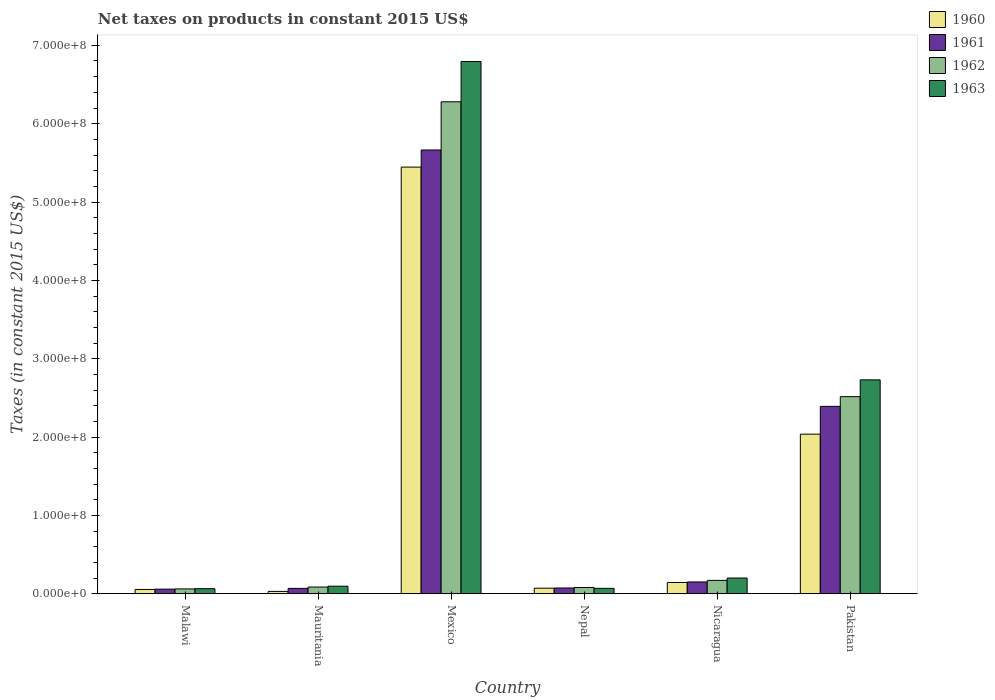Are the number of bars per tick equal to the number of legend labels?
Your response must be concise. Yes. Are the number of bars on each tick of the X-axis equal?
Keep it short and to the point. Yes. How many bars are there on the 1st tick from the left?
Make the answer very short. 4. What is the label of the 2nd group of bars from the left?
Your answer should be very brief. Mauritania. In how many cases, is the number of bars for a given country not equal to the number of legend labels?
Offer a very short reply. 0. What is the net taxes on products in 1963 in Nicaragua?
Give a very brief answer. 2.01e+07. Across all countries, what is the maximum net taxes on products in 1960?
Offer a very short reply. 5.45e+08. Across all countries, what is the minimum net taxes on products in 1960?
Provide a succinct answer. 3.00e+06. In which country was the net taxes on products in 1960 maximum?
Offer a very short reply. Mexico. In which country was the net taxes on products in 1960 minimum?
Your answer should be compact. Mauritania. What is the total net taxes on products in 1960 in the graph?
Provide a short and direct response. 7.78e+08. What is the difference between the net taxes on products in 1963 in Mexico and that in Pakistan?
Your answer should be very brief. 4.06e+08. What is the difference between the net taxes on products in 1961 in Malawi and the net taxes on products in 1963 in Nicaragua?
Provide a succinct answer. -1.42e+07. What is the average net taxes on products in 1963 per country?
Offer a terse response. 1.66e+08. What is the difference between the net taxes on products of/in 1962 and net taxes on products of/in 1960 in Malawi?
Give a very brief answer. 7.00e+05. What is the ratio of the net taxes on products in 1960 in Nicaragua to that in Pakistan?
Your answer should be very brief. 0.07. Is the difference between the net taxes on products in 1962 in Nepal and Pakistan greater than the difference between the net taxes on products in 1960 in Nepal and Pakistan?
Keep it short and to the point. No. What is the difference between the highest and the second highest net taxes on products in 1960?
Your answer should be compact. 1.89e+08. What is the difference between the highest and the lowest net taxes on products in 1960?
Your answer should be very brief. 5.42e+08. Is it the case that in every country, the sum of the net taxes on products in 1960 and net taxes on products in 1961 is greater than the sum of net taxes on products in 1963 and net taxes on products in 1962?
Your answer should be very brief. No. What does the 1st bar from the left in Mauritania represents?
Offer a very short reply. 1960. What does the 1st bar from the right in Mexico represents?
Provide a succinct answer. 1963. Is it the case that in every country, the sum of the net taxes on products in 1960 and net taxes on products in 1963 is greater than the net taxes on products in 1961?
Ensure brevity in your answer.  Yes. Are the values on the major ticks of Y-axis written in scientific E-notation?
Your answer should be very brief. Yes. Does the graph contain any zero values?
Your response must be concise. No. Does the graph contain grids?
Make the answer very short. No. What is the title of the graph?
Your answer should be compact. Net taxes on products in constant 2015 US$. What is the label or title of the X-axis?
Give a very brief answer. Country. What is the label or title of the Y-axis?
Provide a succinct answer. Taxes (in constant 2015 US$). What is the Taxes (in constant 2015 US$) of 1960 in Malawi?
Your answer should be compact. 5.46e+06. What is the Taxes (in constant 2015 US$) of 1961 in Malawi?
Provide a short and direct response. 5.88e+06. What is the Taxes (in constant 2015 US$) of 1962 in Malawi?
Your response must be concise. 6.16e+06. What is the Taxes (in constant 2015 US$) in 1963 in Malawi?
Offer a very short reply. 6.44e+06. What is the Taxes (in constant 2015 US$) in 1960 in Mauritania?
Provide a succinct answer. 3.00e+06. What is the Taxes (in constant 2015 US$) in 1961 in Mauritania?
Your answer should be very brief. 6.85e+06. What is the Taxes (in constant 2015 US$) in 1962 in Mauritania?
Your answer should be very brief. 8.56e+06. What is the Taxes (in constant 2015 US$) of 1963 in Mauritania?
Provide a succinct answer. 9.63e+06. What is the Taxes (in constant 2015 US$) in 1960 in Mexico?
Make the answer very short. 5.45e+08. What is the Taxes (in constant 2015 US$) in 1961 in Mexico?
Ensure brevity in your answer.  5.66e+08. What is the Taxes (in constant 2015 US$) of 1962 in Mexico?
Offer a very short reply. 6.28e+08. What is the Taxes (in constant 2015 US$) in 1963 in Mexico?
Offer a terse response. 6.79e+08. What is the Taxes (in constant 2015 US$) in 1960 in Nepal?
Offer a very short reply. 7.09e+06. What is the Taxes (in constant 2015 US$) of 1961 in Nepal?
Ensure brevity in your answer.  7.35e+06. What is the Taxes (in constant 2015 US$) of 1962 in Nepal?
Your answer should be very brief. 8.01e+06. What is the Taxes (in constant 2015 US$) of 1963 in Nepal?
Make the answer very short. 6.89e+06. What is the Taxes (in constant 2015 US$) in 1960 in Nicaragua?
Give a very brief answer. 1.44e+07. What is the Taxes (in constant 2015 US$) of 1961 in Nicaragua?
Make the answer very short. 1.51e+07. What is the Taxes (in constant 2015 US$) of 1962 in Nicaragua?
Ensure brevity in your answer.  1.71e+07. What is the Taxes (in constant 2015 US$) in 1963 in Nicaragua?
Your answer should be very brief. 2.01e+07. What is the Taxes (in constant 2015 US$) in 1960 in Pakistan?
Provide a succinct answer. 2.04e+08. What is the Taxes (in constant 2015 US$) in 1961 in Pakistan?
Your response must be concise. 2.39e+08. What is the Taxes (in constant 2015 US$) of 1962 in Pakistan?
Your answer should be compact. 2.52e+08. What is the Taxes (in constant 2015 US$) of 1963 in Pakistan?
Offer a very short reply. 2.73e+08. Across all countries, what is the maximum Taxes (in constant 2015 US$) of 1960?
Your response must be concise. 5.45e+08. Across all countries, what is the maximum Taxes (in constant 2015 US$) of 1961?
Your answer should be compact. 5.66e+08. Across all countries, what is the maximum Taxes (in constant 2015 US$) of 1962?
Ensure brevity in your answer.  6.28e+08. Across all countries, what is the maximum Taxes (in constant 2015 US$) in 1963?
Your answer should be compact. 6.79e+08. Across all countries, what is the minimum Taxes (in constant 2015 US$) in 1960?
Give a very brief answer. 3.00e+06. Across all countries, what is the minimum Taxes (in constant 2015 US$) in 1961?
Make the answer very short. 5.88e+06. Across all countries, what is the minimum Taxes (in constant 2015 US$) in 1962?
Ensure brevity in your answer.  6.16e+06. Across all countries, what is the minimum Taxes (in constant 2015 US$) of 1963?
Give a very brief answer. 6.44e+06. What is the total Taxes (in constant 2015 US$) in 1960 in the graph?
Provide a short and direct response. 7.78e+08. What is the total Taxes (in constant 2015 US$) of 1961 in the graph?
Offer a terse response. 8.41e+08. What is the total Taxes (in constant 2015 US$) of 1962 in the graph?
Provide a succinct answer. 9.19e+08. What is the total Taxes (in constant 2015 US$) of 1963 in the graph?
Make the answer very short. 9.95e+08. What is the difference between the Taxes (in constant 2015 US$) in 1960 in Malawi and that in Mauritania?
Your answer should be very brief. 2.46e+06. What is the difference between the Taxes (in constant 2015 US$) of 1961 in Malawi and that in Mauritania?
Make the answer very short. -9.67e+05. What is the difference between the Taxes (in constant 2015 US$) of 1962 in Malawi and that in Mauritania?
Keep it short and to the point. -2.40e+06. What is the difference between the Taxes (in constant 2015 US$) of 1963 in Malawi and that in Mauritania?
Offer a very short reply. -3.19e+06. What is the difference between the Taxes (in constant 2015 US$) of 1960 in Malawi and that in Mexico?
Your response must be concise. -5.39e+08. What is the difference between the Taxes (in constant 2015 US$) in 1961 in Malawi and that in Mexico?
Your answer should be compact. -5.61e+08. What is the difference between the Taxes (in constant 2015 US$) of 1962 in Malawi and that in Mexico?
Ensure brevity in your answer.  -6.22e+08. What is the difference between the Taxes (in constant 2015 US$) of 1963 in Malawi and that in Mexico?
Give a very brief answer. -6.73e+08. What is the difference between the Taxes (in constant 2015 US$) of 1960 in Malawi and that in Nepal?
Offer a terse response. -1.63e+06. What is the difference between the Taxes (in constant 2015 US$) in 1961 in Malawi and that in Nepal?
Give a very brief answer. -1.47e+06. What is the difference between the Taxes (in constant 2015 US$) of 1962 in Malawi and that in Nepal?
Your answer should be compact. -1.85e+06. What is the difference between the Taxes (in constant 2015 US$) in 1963 in Malawi and that in Nepal?
Make the answer very short. -4.50e+05. What is the difference between the Taxes (in constant 2015 US$) in 1960 in Malawi and that in Nicaragua?
Your response must be concise. -8.93e+06. What is the difference between the Taxes (in constant 2015 US$) of 1961 in Malawi and that in Nicaragua?
Give a very brief answer. -9.18e+06. What is the difference between the Taxes (in constant 2015 US$) in 1962 in Malawi and that in Nicaragua?
Make the answer very short. -1.09e+07. What is the difference between the Taxes (in constant 2015 US$) in 1963 in Malawi and that in Nicaragua?
Offer a very short reply. -1.36e+07. What is the difference between the Taxes (in constant 2015 US$) in 1960 in Malawi and that in Pakistan?
Offer a terse response. -1.98e+08. What is the difference between the Taxes (in constant 2015 US$) in 1961 in Malawi and that in Pakistan?
Offer a very short reply. -2.33e+08. What is the difference between the Taxes (in constant 2015 US$) in 1962 in Malawi and that in Pakistan?
Offer a very short reply. -2.45e+08. What is the difference between the Taxes (in constant 2015 US$) of 1963 in Malawi and that in Pakistan?
Your response must be concise. -2.67e+08. What is the difference between the Taxes (in constant 2015 US$) in 1960 in Mauritania and that in Mexico?
Give a very brief answer. -5.42e+08. What is the difference between the Taxes (in constant 2015 US$) of 1961 in Mauritania and that in Mexico?
Your answer should be very brief. -5.60e+08. What is the difference between the Taxes (in constant 2015 US$) of 1962 in Mauritania and that in Mexico?
Keep it short and to the point. -6.19e+08. What is the difference between the Taxes (in constant 2015 US$) in 1963 in Mauritania and that in Mexico?
Provide a short and direct response. -6.70e+08. What is the difference between the Taxes (in constant 2015 US$) of 1960 in Mauritania and that in Nepal?
Your answer should be compact. -4.09e+06. What is the difference between the Taxes (in constant 2015 US$) in 1961 in Mauritania and that in Nepal?
Your answer should be compact. -5.03e+05. What is the difference between the Taxes (in constant 2015 US$) in 1962 in Mauritania and that in Nepal?
Ensure brevity in your answer.  5.53e+05. What is the difference between the Taxes (in constant 2015 US$) of 1963 in Mauritania and that in Nepal?
Offer a terse response. 2.74e+06. What is the difference between the Taxes (in constant 2015 US$) of 1960 in Mauritania and that in Nicaragua?
Ensure brevity in your answer.  -1.14e+07. What is the difference between the Taxes (in constant 2015 US$) in 1961 in Mauritania and that in Nicaragua?
Offer a terse response. -8.21e+06. What is the difference between the Taxes (in constant 2015 US$) in 1962 in Mauritania and that in Nicaragua?
Your answer should be compact. -8.50e+06. What is the difference between the Taxes (in constant 2015 US$) in 1963 in Mauritania and that in Nicaragua?
Make the answer very short. -1.04e+07. What is the difference between the Taxes (in constant 2015 US$) of 1960 in Mauritania and that in Pakistan?
Keep it short and to the point. -2.01e+08. What is the difference between the Taxes (in constant 2015 US$) in 1961 in Mauritania and that in Pakistan?
Your answer should be compact. -2.32e+08. What is the difference between the Taxes (in constant 2015 US$) in 1962 in Mauritania and that in Pakistan?
Ensure brevity in your answer.  -2.43e+08. What is the difference between the Taxes (in constant 2015 US$) in 1963 in Mauritania and that in Pakistan?
Make the answer very short. -2.63e+08. What is the difference between the Taxes (in constant 2015 US$) of 1960 in Mexico and that in Nepal?
Ensure brevity in your answer.  5.37e+08. What is the difference between the Taxes (in constant 2015 US$) in 1961 in Mexico and that in Nepal?
Keep it short and to the point. 5.59e+08. What is the difference between the Taxes (in constant 2015 US$) of 1962 in Mexico and that in Nepal?
Provide a succinct answer. 6.20e+08. What is the difference between the Taxes (in constant 2015 US$) of 1963 in Mexico and that in Nepal?
Your answer should be compact. 6.72e+08. What is the difference between the Taxes (in constant 2015 US$) of 1960 in Mexico and that in Nicaragua?
Ensure brevity in your answer.  5.30e+08. What is the difference between the Taxes (in constant 2015 US$) of 1961 in Mexico and that in Nicaragua?
Offer a very short reply. 5.51e+08. What is the difference between the Taxes (in constant 2015 US$) of 1962 in Mexico and that in Nicaragua?
Ensure brevity in your answer.  6.11e+08. What is the difference between the Taxes (in constant 2015 US$) in 1963 in Mexico and that in Nicaragua?
Your answer should be compact. 6.59e+08. What is the difference between the Taxes (in constant 2015 US$) of 1960 in Mexico and that in Pakistan?
Keep it short and to the point. 3.41e+08. What is the difference between the Taxes (in constant 2015 US$) in 1961 in Mexico and that in Pakistan?
Your response must be concise. 3.27e+08. What is the difference between the Taxes (in constant 2015 US$) of 1962 in Mexico and that in Pakistan?
Offer a very short reply. 3.76e+08. What is the difference between the Taxes (in constant 2015 US$) of 1963 in Mexico and that in Pakistan?
Your answer should be compact. 4.06e+08. What is the difference between the Taxes (in constant 2015 US$) of 1960 in Nepal and that in Nicaragua?
Give a very brief answer. -7.30e+06. What is the difference between the Taxes (in constant 2015 US$) of 1961 in Nepal and that in Nicaragua?
Provide a succinct answer. -7.71e+06. What is the difference between the Taxes (in constant 2015 US$) in 1962 in Nepal and that in Nicaragua?
Offer a very short reply. -9.06e+06. What is the difference between the Taxes (in constant 2015 US$) in 1963 in Nepal and that in Nicaragua?
Your answer should be very brief. -1.32e+07. What is the difference between the Taxes (in constant 2015 US$) of 1960 in Nepal and that in Pakistan?
Provide a short and direct response. -1.97e+08. What is the difference between the Taxes (in constant 2015 US$) of 1961 in Nepal and that in Pakistan?
Ensure brevity in your answer.  -2.32e+08. What is the difference between the Taxes (in constant 2015 US$) in 1962 in Nepal and that in Pakistan?
Make the answer very short. -2.44e+08. What is the difference between the Taxes (in constant 2015 US$) of 1963 in Nepal and that in Pakistan?
Keep it short and to the point. -2.66e+08. What is the difference between the Taxes (in constant 2015 US$) of 1960 in Nicaragua and that in Pakistan?
Give a very brief answer. -1.89e+08. What is the difference between the Taxes (in constant 2015 US$) of 1961 in Nicaragua and that in Pakistan?
Offer a terse response. -2.24e+08. What is the difference between the Taxes (in constant 2015 US$) in 1962 in Nicaragua and that in Pakistan?
Your answer should be very brief. -2.35e+08. What is the difference between the Taxes (in constant 2015 US$) of 1963 in Nicaragua and that in Pakistan?
Give a very brief answer. -2.53e+08. What is the difference between the Taxes (in constant 2015 US$) of 1960 in Malawi and the Taxes (in constant 2015 US$) of 1961 in Mauritania?
Provide a short and direct response. -1.39e+06. What is the difference between the Taxes (in constant 2015 US$) in 1960 in Malawi and the Taxes (in constant 2015 US$) in 1962 in Mauritania?
Your answer should be compact. -3.10e+06. What is the difference between the Taxes (in constant 2015 US$) of 1960 in Malawi and the Taxes (in constant 2015 US$) of 1963 in Mauritania?
Keep it short and to the point. -4.17e+06. What is the difference between the Taxes (in constant 2015 US$) of 1961 in Malawi and the Taxes (in constant 2015 US$) of 1962 in Mauritania?
Ensure brevity in your answer.  -2.68e+06. What is the difference between the Taxes (in constant 2015 US$) in 1961 in Malawi and the Taxes (in constant 2015 US$) in 1963 in Mauritania?
Keep it short and to the point. -3.75e+06. What is the difference between the Taxes (in constant 2015 US$) of 1962 in Malawi and the Taxes (in constant 2015 US$) of 1963 in Mauritania?
Your answer should be very brief. -3.47e+06. What is the difference between the Taxes (in constant 2015 US$) of 1960 in Malawi and the Taxes (in constant 2015 US$) of 1961 in Mexico?
Your answer should be very brief. -5.61e+08. What is the difference between the Taxes (in constant 2015 US$) in 1960 in Malawi and the Taxes (in constant 2015 US$) in 1962 in Mexico?
Your response must be concise. -6.22e+08. What is the difference between the Taxes (in constant 2015 US$) in 1960 in Malawi and the Taxes (in constant 2015 US$) in 1963 in Mexico?
Your answer should be compact. -6.74e+08. What is the difference between the Taxes (in constant 2015 US$) of 1961 in Malawi and the Taxes (in constant 2015 US$) of 1962 in Mexico?
Provide a succinct answer. -6.22e+08. What is the difference between the Taxes (in constant 2015 US$) in 1961 in Malawi and the Taxes (in constant 2015 US$) in 1963 in Mexico?
Offer a terse response. -6.73e+08. What is the difference between the Taxes (in constant 2015 US$) in 1962 in Malawi and the Taxes (in constant 2015 US$) in 1963 in Mexico?
Your answer should be compact. -6.73e+08. What is the difference between the Taxes (in constant 2015 US$) of 1960 in Malawi and the Taxes (in constant 2015 US$) of 1961 in Nepal?
Your answer should be compact. -1.89e+06. What is the difference between the Taxes (in constant 2015 US$) in 1960 in Malawi and the Taxes (in constant 2015 US$) in 1962 in Nepal?
Provide a short and direct response. -2.55e+06. What is the difference between the Taxes (in constant 2015 US$) of 1960 in Malawi and the Taxes (in constant 2015 US$) of 1963 in Nepal?
Your response must be concise. -1.43e+06. What is the difference between the Taxes (in constant 2015 US$) of 1961 in Malawi and the Taxes (in constant 2015 US$) of 1962 in Nepal?
Give a very brief answer. -2.13e+06. What is the difference between the Taxes (in constant 2015 US$) in 1961 in Malawi and the Taxes (in constant 2015 US$) in 1963 in Nepal?
Your answer should be compact. -1.01e+06. What is the difference between the Taxes (in constant 2015 US$) of 1962 in Malawi and the Taxes (in constant 2015 US$) of 1963 in Nepal?
Your response must be concise. -7.30e+05. What is the difference between the Taxes (in constant 2015 US$) in 1960 in Malawi and the Taxes (in constant 2015 US$) in 1961 in Nicaragua?
Provide a short and direct response. -9.60e+06. What is the difference between the Taxes (in constant 2015 US$) of 1960 in Malawi and the Taxes (in constant 2015 US$) of 1962 in Nicaragua?
Offer a very short reply. -1.16e+07. What is the difference between the Taxes (in constant 2015 US$) of 1960 in Malawi and the Taxes (in constant 2015 US$) of 1963 in Nicaragua?
Provide a succinct answer. -1.46e+07. What is the difference between the Taxes (in constant 2015 US$) of 1961 in Malawi and the Taxes (in constant 2015 US$) of 1962 in Nicaragua?
Your response must be concise. -1.12e+07. What is the difference between the Taxes (in constant 2015 US$) in 1961 in Malawi and the Taxes (in constant 2015 US$) in 1963 in Nicaragua?
Your answer should be compact. -1.42e+07. What is the difference between the Taxes (in constant 2015 US$) in 1962 in Malawi and the Taxes (in constant 2015 US$) in 1963 in Nicaragua?
Offer a terse response. -1.39e+07. What is the difference between the Taxes (in constant 2015 US$) of 1960 in Malawi and the Taxes (in constant 2015 US$) of 1961 in Pakistan?
Offer a very short reply. -2.34e+08. What is the difference between the Taxes (in constant 2015 US$) of 1960 in Malawi and the Taxes (in constant 2015 US$) of 1962 in Pakistan?
Make the answer very short. -2.46e+08. What is the difference between the Taxes (in constant 2015 US$) in 1960 in Malawi and the Taxes (in constant 2015 US$) in 1963 in Pakistan?
Your response must be concise. -2.68e+08. What is the difference between the Taxes (in constant 2015 US$) in 1961 in Malawi and the Taxes (in constant 2015 US$) in 1962 in Pakistan?
Your answer should be very brief. -2.46e+08. What is the difference between the Taxes (in constant 2015 US$) in 1961 in Malawi and the Taxes (in constant 2015 US$) in 1963 in Pakistan?
Ensure brevity in your answer.  -2.67e+08. What is the difference between the Taxes (in constant 2015 US$) of 1962 in Malawi and the Taxes (in constant 2015 US$) of 1963 in Pakistan?
Provide a succinct answer. -2.67e+08. What is the difference between the Taxes (in constant 2015 US$) of 1960 in Mauritania and the Taxes (in constant 2015 US$) of 1961 in Mexico?
Your answer should be compact. -5.63e+08. What is the difference between the Taxes (in constant 2015 US$) of 1960 in Mauritania and the Taxes (in constant 2015 US$) of 1962 in Mexico?
Provide a short and direct response. -6.25e+08. What is the difference between the Taxes (in constant 2015 US$) of 1960 in Mauritania and the Taxes (in constant 2015 US$) of 1963 in Mexico?
Provide a succinct answer. -6.76e+08. What is the difference between the Taxes (in constant 2015 US$) of 1961 in Mauritania and the Taxes (in constant 2015 US$) of 1962 in Mexico?
Your response must be concise. -6.21e+08. What is the difference between the Taxes (in constant 2015 US$) in 1961 in Mauritania and the Taxes (in constant 2015 US$) in 1963 in Mexico?
Provide a short and direct response. -6.73e+08. What is the difference between the Taxes (in constant 2015 US$) of 1962 in Mauritania and the Taxes (in constant 2015 US$) of 1963 in Mexico?
Give a very brief answer. -6.71e+08. What is the difference between the Taxes (in constant 2015 US$) in 1960 in Mauritania and the Taxes (in constant 2015 US$) in 1961 in Nepal?
Offer a very short reply. -4.35e+06. What is the difference between the Taxes (in constant 2015 US$) of 1960 in Mauritania and the Taxes (in constant 2015 US$) of 1962 in Nepal?
Provide a succinct answer. -5.01e+06. What is the difference between the Taxes (in constant 2015 US$) in 1960 in Mauritania and the Taxes (in constant 2015 US$) in 1963 in Nepal?
Keep it short and to the point. -3.89e+06. What is the difference between the Taxes (in constant 2015 US$) of 1961 in Mauritania and the Taxes (in constant 2015 US$) of 1962 in Nepal?
Ensure brevity in your answer.  -1.16e+06. What is the difference between the Taxes (in constant 2015 US$) in 1961 in Mauritania and the Taxes (in constant 2015 US$) in 1963 in Nepal?
Make the answer very short. -4.29e+04. What is the difference between the Taxes (in constant 2015 US$) of 1962 in Mauritania and the Taxes (in constant 2015 US$) of 1963 in Nepal?
Ensure brevity in your answer.  1.67e+06. What is the difference between the Taxes (in constant 2015 US$) of 1960 in Mauritania and the Taxes (in constant 2015 US$) of 1961 in Nicaragua?
Your response must be concise. -1.21e+07. What is the difference between the Taxes (in constant 2015 US$) of 1960 in Mauritania and the Taxes (in constant 2015 US$) of 1962 in Nicaragua?
Provide a succinct answer. -1.41e+07. What is the difference between the Taxes (in constant 2015 US$) of 1960 in Mauritania and the Taxes (in constant 2015 US$) of 1963 in Nicaragua?
Your response must be concise. -1.71e+07. What is the difference between the Taxes (in constant 2015 US$) of 1961 in Mauritania and the Taxes (in constant 2015 US$) of 1962 in Nicaragua?
Ensure brevity in your answer.  -1.02e+07. What is the difference between the Taxes (in constant 2015 US$) in 1961 in Mauritania and the Taxes (in constant 2015 US$) in 1963 in Nicaragua?
Your response must be concise. -1.32e+07. What is the difference between the Taxes (in constant 2015 US$) of 1962 in Mauritania and the Taxes (in constant 2015 US$) of 1963 in Nicaragua?
Give a very brief answer. -1.15e+07. What is the difference between the Taxes (in constant 2015 US$) of 1960 in Mauritania and the Taxes (in constant 2015 US$) of 1961 in Pakistan?
Provide a succinct answer. -2.36e+08. What is the difference between the Taxes (in constant 2015 US$) in 1960 in Mauritania and the Taxes (in constant 2015 US$) in 1962 in Pakistan?
Offer a very short reply. -2.49e+08. What is the difference between the Taxes (in constant 2015 US$) of 1960 in Mauritania and the Taxes (in constant 2015 US$) of 1963 in Pakistan?
Provide a short and direct response. -2.70e+08. What is the difference between the Taxes (in constant 2015 US$) in 1961 in Mauritania and the Taxes (in constant 2015 US$) in 1962 in Pakistan?
Provide a succinct answer. -2.45e+08. What is the difference between the Taxes (in constant 2015 US$) in 1961 in Mauritania and the Taxes (in constant 2015 US$) in 1963 in Pakistan?
Provide a short and direct response. -2.66e+08. What is the difference between the Taxes (in constant 2015 US$) in 1962 in Mauritania and the Taxes (in constant 2015 US$) in 1963 in Pakistan?
Provide a succinct answer. -2.64e+08. What is the difference between the Taxes (in constant 2015 US$) of 1960 in Mexico and the Taxes (in constant 2015 US$) of 1961 in Nepal?
Keep it short and to the point. 5.37e+08. What is the difference between the Taxes (in constant 2015 US$) of 1960 in Mexico and the Taxes (in constant 2015 US$) of 1962 in Nepal?
Keep it short and to the point. 5.37e+08. What is the difference between the Taxes (in constant 2015 US$) in 1960 in Mexico and the Taxes (in constant 2015 US$) in 1963 in Nepal?
Give a very brief answer. 5.38e+08. What is the difference between the Taxes (in constant 2015 US$) in 1961 in Mexico and the Taxes (in constant 2015 US$) in 1962 in Nepal?
Your answer should be very brief. 5.58e+08. What is the difference between the Taxes (in constant 2015 US$) in 1961 in Mexico and the Taxes (in constant 2015 US$) in 1963 in Nepal?
Provide a succinct answer. 5.60e+08. What is the difference between the Taxes (in constant 2015 US$) in 1962 in Mexico and the Taxes (in constant 2015 US$) in 1963 in Nepal?
Offer a terse response. 6.21e+08. What is the difference between the Taxes (in constant 2015 US$) in 1960 in Mexico and the Taxes (in constant 2015 US$) in 1961 in Nicaragua?
Ensure brevity in your answer.  5.30e+08. What is the difference between the Taxes (in constant 2015 US$) of 1960 in Mexico and the Taxes (in constant 2015 US$) of 1962 in Nicaragua?
Provide a succinct answer. 5.28e+08. What is the difference between the Taxes (in constant 2015 US$) in 1960 in Mexico and the Taxes (in constant 2015 US$) in 1963 in Nicaragua?
Give a very brief answer. 5.24e+08. What is the difference between the Taxes (in constant 2015 US$) in 1961 in Mexico and the Taxes (in constant 2015 US$) in 1962 in Nicaragua?
Your response must be concise. 5.49e+08. What is the difference between the Taxes (in constant 2015 US$) of 1961 in Mexico and the Taxes (in constant 2015 US$) of 1963 in Nicaragua?
Keep it short and to the point. 5.46e+08. What is the difference between the Taxes (in constant 2015 US$) of 1962 in Mexico and the Taxes (in constant 2015 US$) of 1963 in Nicaragua?
Your answer should be compact. 6.08e+08. What is the difference between the Taxes (in constant 2015 US$) in 1960 in Mexico and the Taxes (in constant 2015 US$) in 1961 in Pakistan?
Your response must be concise. 3.05e+08. What is the difference between the Taxes (in constant 2015 US$) in 1960 in Mexico and the Taxes (in constant 2015 US$) in 1962 in Pakistan?
Ensure brevity in your answer.  2.93e+08. What is the difference between the Taxes (in constant 2015 US$) of 1960 in Mexico and the Taxes (in constant 2015 US$) of 1963 in Pakistan?
Offer a terse response. 2.72e+08. What is the difference between the Taxes (in constant 2015 US$) of 1961 in Mexico and the Taxes (in constant 2015 US$) of 1962 in Pakistan?
Provide a short and direct response. 3.15e+08. What is the difference between the Taxes (in constant 2015 US$) in 1961 in Mexico and the Taxes (in constant 2015 US$) in 1963 in Pakistan?
Keep it short and to the point. 2.93e+08. What is the difference between the Taxes (in constant 2015 US$) of 1962 in Mexico and the Taxes (in constant 2015 US$) of 1963 in Pakistan?
Your response must be concise. 3.55e+08. What is the difference between the Taxes (in constant 2015 US$) in 1960 in Nepal and the Taxes (in constant 2015 US$) in 1961 in Nicaragua?
Offer a very short reply. -7.97e+06. What is the difference between the Taxes (in constant 2015 US$) in 1960 in Nepal and the Taxes (in constant 2015 US$) in 1962 in Nicaragua?
Make the answer very short. -9.98e+06. What is the difference between the Taxes (in constant 2015 US$) of 1960 in Nepal and the Taxes (in constant 2015 US$) of 1963 in Nicaragua?
Your response must be concise. -1.30e+07. What is the difference between the Taxes (in constant 2015 US$) in 1961 in Nepal and the Taxes (in constant 2015 US$) in 1962 in Nicaragua?
Your response must be concise. -9.71e+06. What is the difference between the Taxes (in constant 2015 US$) in 1961 in Nepal and the Taxes (in constant 2015 US$) in 1963 in Nicaragua?
Your answer should be very brief. -1.27e+07. What is the difference between the Taxes (in constant 2015 US$) in 1962 in Nepal and the Taxes (in constant 2015 US$) in 1963 in Nicaragua?
Offer a terse response. -1.21e+07. What is the difference between the Taxes (in constant 2015 US$) of 1960 in Nepal and the Taxes (in constant 2015 US$) of 1961 in Pakistan?
Offer a terse response. -2.32e+08. What is the difference between the Taxes (in constant 2015 US$) in 1960 in Nepal and the Taxes (in constant 2015 US$) in 1962 in Pakistan?
Keep it short and to the point. -2.44e+08. What is the difference between the Taxes (in constant 2015 US$) in 1960 in Nepal and the Taxes (in constant 2015 US$) in 1963 in Pakistan?
Your response must be concise. -2.66e+08. What is the difference between the Taxes (in constant 2015 US$) in 1961 in Nepal and the Taxes (in constant 2015 US$) in 1962 in Pakistan?
Your answer should be compact. -2.44e+08. What is the difference between the Taxes (in constant 2015 US$) in 1961 in Nepal and the Taxes (in constant 2015 US$) in 1963 in Pakistan?
Your answer should be compact. -2.66e+08. What is the difference between the Taxes (in constant 2015 US$) of 1962 in Nepal and the Taxes (in constant 2015 US$) of 1963 in Pakistan?
Offer a very short reply. -2.65e+08. What is the difference between the Taxes (in constant 2015 US$) in 1960 in Nicaragua and the Taxes (in constant 2015 US$) in 1961 in Pakistan?
Your answer should be very brief. -2.25e+08. What is the difference between the Taxes (in constant 2015 US$) of 1960 in Nicaragua and the Taxes (in constant 2015 US$) of 1962 in Pakistan?
Offer a very short reply. -2.37e+08. What is the difference between the Taxes (in constant 2015 US$) in 1960 in Nicaragua and the Taxes (in constant 2015 US$) in 1963 in Pakistan?
Offer a very short reply. -2.59e+08. What is the difference between the Taxes (in constant 2015 US$) in 1961 in Nicaragua and the Taxes (in constant 2015 US$) in 1962 in Pakistan?
Your answer should be compact. -2.37e+08. What is the difference between the Taxes (in constant 2015 US$) in 1961 in Nicaragua and the Taxes (in constant 2015 US$) in 1963 in Pakistan?
Give a very brief answer. -2.58e+08. What is the difference between the Taxes (in constant 2015 US$) in 1962 in Nicaragua and the Taxes (in constant 2015 US$) in 1963 in Pakistan?
Your answer should be compact. -2.56e+08. What is the average Taxes (in constant 2015 US$) in 1960 per country?
Offer a very short reply. 1.30e+08. What is the average Taxes (in constant 2015 US$) of 1961 per country?
Your answer should be compact. 1.40e+08. What is the average Taxes (in constant 2015 US$) of 1962 per country?
Your answer should be very brief. 1.53e+08. What is the average Taxes (in constant 2015 US$) of 1963 per country?
Ensure brevity in your answer.  1.66e+08. What is the difference between the Taxes (in constant 2015 US$) in 1960 and Taxes (in constant 2015 US$) in 1961 in Malawi?
Ensure brevity in your answer.  -4.20e+05. What is the difference between the Taxes (in constant 2015 US$) of 1960 and Taxes (in constant 2015 US$) of 1962 in Malawi?
Give a very brief answer. -7.00e+05. What is the difference between the Taxes (in constant 2015 US$) in 1960 and Taxes (in constant 2015 US$) in 1963 in Malawi?
Give a very brief answer. -9.80e+05. What is the difference between the Taxes (in constant 2015 US$) of 1961 and Taxes (in constant 2015 US$) of 1962 in Malawi?
Make the answer very short. -2.80e+05. What is the difference between the Taxes (in constant 2015 US$) in 1961 and Taxes (in constant 2015 US$) in 1963 in Malawi?
Make the answer very short. -5.60e+05. What is the difference between the Taxes (in constant 2015 US$) in 1962 and Taxes (in constant 2015 US$) in 1963 in Malawi?
Make the answer very short. -2.80e+05. What is the difference between the Taxes (in constant 2015 US$) of 1960 and Taxes (in constant 2015 US$) of 1961 in Mauritania?
Your answer should be very brief. -3.85e+06. What is the difference between the Taxes (in constant 2015 US$) in 1960 and Taxes (in constant 2015 US$) in 1962 in Mauritania?
Your response must be concise. -5.56e+06. What is the difference between the Taxes (in constant 2015 US$) of 1960 and Taxes (in constant 2015 US$) of 1963 in Mauritania?
Offer a very short reply. -6.63e+06. What is the difference between the Taxes (in constant 2015 US$) in 1961 and Taxes (in constant 2015 US$) in 1962 in Mauritania?
Offer a terse response. -1.71e+06. What is the difference between the Taxes (in constant 2015 US$) of 1961 and Taxes (in constant 2015 US$) of 1963 in Mauritania?
Give a very brief answer. -2.78e+06. What is the difference between the Taxes (in constant 2015 US$) in 1962 and Taxes (in constant 2015 US$) in 1963 in Mauritania?
Keep it short and to the point. -1.07e+06. What is the difference between the Taxes (in constant 2015 US$) of 1960 and Taxes (in constant 2015 US$) of 1961 in Mexico?
Give a very brief answer. -2.18e+07. What is the difference between the Taxes (in constant 2015 US$) of 1960 and Taxes (in constant 2015 US$) of 1962 in Mexico?
Your answer should be compact. -8.34e+07. What is the difference between the Taxes (in constant 2015 US$) of 1960 and Taxes (in constant 2015 US$) of 1963 in Mexico?
Your answer should be compact. -1.35e+08. What is the difference between the Taxes (in constant 2015 US$) of 1961 and Taxes (in constant 2015 US$) of 1962 in Mexico?
Your response must be concise. -6.15e+07. What is the difference between the Taxes (in constant 2015 US$) of 1961 and Taxes (in constant 2015 US$) of 1963 in Mexico?
Keep it short and to the point. -1.13e+08. What is the difference between the Taxes (in constant 2015 US$) of 1962 and Taxes (in constant 2015 US$) of 1963 in Mexico?
Give a very brief answer. -5.14e+07. What is the difference between the Taxes (in constant 2015 US$) of 1960 and Taxes (in constant 2015 US$) of 1961 in Nepal?
Offer a very short reply. -2.63e+05. What is the difference between the Taxes (in constant 2015 US$) of 1960 and Taxes (in constant 2015 US$) of 1962 in Nepal?
Give a very brief answer. -9.19e+05. What is the difference between the Taxes (in constant 2015 US$) in 1960 and Taxes (in constant 2015 US$) in 1963 in Nepal?
Provide a short and direct response. 1.97e+05. What is the difference between the Taxes (in constant 2015 US$) of 1961 and Taxes (in constant 2015 US$) of 1962 in Nepal?
Offer a terse response. -6.56e+05. What is the difference between the Taxes (in constant 2015 US$) of 1961 and Taxes (in constant 2015 US$) of 1963 in Nepal?
Keep it short and to the point. 4.60e+05. What is the difference between the Taxes (in constant 2015 US$) of 1962 and Taxes (in constant 2015 US$) of 1963 in Nepal?
Give a very brief answer. 1.12e+06. What is the difference between the Taxes (in constant 2015 US$) in 1960 and Taxes (in constant 2015 US$) in 1961 in Nicaragua?
Provide a succinct answer. -6.69e+05. What is the difference between the Taxes (in constant 2015 US$) in 1960 and Taxes (in constant 2015 US$) in 1962 in Nicaragua?
Make the answer very short. -2.68e+06. What is the difference between the Taxes (in constant 2015 US$) of 1960 and Taxes (in constant 2015 US$) of 1963 in Nicaragua?
Offer a very short reply. -5.69e+06. What is the difference between the Taxes (in constant 2015 US$) in 1961 and Taxes (in constant 2015 US$) in 1962 in Nicaragua?
Make the answer very short. -2.01e+06. What is the difference between the Taxes (in constant 2015 US$) of 1961 and Taxes (in constant 2015 US$) of 1963 in Nicaragua?
Offer a terse response. -5.02e+06. What is the difference between the Taxes (in constant 2015 US$) in 1962 and Taxes (in constant 2015 US$) in 1963 in Nicaragua?
Offer a very short reply. -3.01e+06. What is the difference between the Taxes (in constant 2015 US$) of 1960 and Taxes (in constant 2015 US$) of 1961 in Pakistan?
Your response must be concise. -3.55e+07. What is the difference between the Taxes (in constant 2015 US$) of 1960 and Taxes (in constant 2015 US$) of 1962 in Pakistan?
Give a very brief answer. -4.79e+07. What is the difference between the Taxes (in constant 2015 US$) of 1960 and Taxes (in constant 2015 US$) of 1963 in Pakistan?
Your answer should be very brief. -6.93e+07. What is the difference between the Taxes (in constant 2015 US$) of 1961 and Taxes (in constant 2015 US$) of 1962 in Pakistan?
Provide a succinct answer. -1.24e+07. What is the difference between the Taxes (in constant 2015 US$) in 1961 and Taxes (in constant 2015 US$) in 1963 in Pakistan?
Your answer should be compact. -3.38e+07. What is the difference between the Taxes (in constant 2015 US$) in 1962 and Taxes (in constant 2015 US$) in 1963 in Pakistan?
Ensure brevity in your answer.  -2.14e+07. What is the ratio of the Taxes (in constant 2015 US$) of 1960 in Malawi to that in Mauritania?
Offer a very short reply. 1.82. What is the ratio of the Taxes (in constant 2015 US$) of 1961 in Malawi to that in Mauritania?
Offer a very short reply. 0.86. What is the ratio of the Taxes (in constant 2015 US$) of 1962 in Malawi to that in Mauritania?
Provide a succinct answer. 0.72. What is the ratio of the Taxes (in constant 2015 US$) of 1963 in Malawi to that in Mauritania?
Your answer should be very brief. 0.67. What is the ratio of the Taxes (in constant 2015 US$) of 1961 in Malawi to that in Mexico?
Keep it short and to the point. 0.01. What is the ratio of the Taxes (in constant 2015 US$) of 1962 in Malawi to that in Mexico?
Make the answer very short. 0.01. What is the ratio of the Taxes (in constant 2015 US$) in 1963 in Malawi to that in Mexico?
Your answer should be very brief. 0.01. What is the ratio of the Taxes (in constant 2015 US$) in 1960 in Malawi to that in Nepal?
Give a very brief answer. 0.77. What is the ratio of the Taxes (in constant 2015 US$) of 1961 in Malawi to that in Nepal?
Offer a very short reply. 0.8. What is the ratio of the Taxes (in constant 2015 US$) in 1962 in Malawi to that in Nepal?
Ensure brevity in your answer.  0.77. What is the ratio of the Taxes (in constant 2015 US$) in 1963 in Malawi to that in Nepal?
Your answer should be very brief. 0.93. What is the ratio of the Taxes (in constant 2015 US$) in 1960 in Malawi to that in Nicaragua?
Your answer should be compact. 0.38. What is the ratio of the Taxes (in constant 2015 US$) in 1961 in Malawi to that in Nicaragua?
Provide a short and direct response. 0.39. What is the ratio of the Taxes (in constant 2015 US$) of 1962 in Malawi to that in Nicaragua?
Your response must be concise. 0.36. What is the ratio of the Taxes (in constant 2015 US$) of 1963 in Malawi to that in Nicaragua?
Provide a succinct answer. 0.32. What is the ratio of the Taxes (in constant 2015 US$) in 1960 in Malawi to that in Pakistan?
Provide a succinct answer. 0.03. What is the ratio of the Taxes (in constant 2015 US$) of 1961 in Malawi to that in Pakistan?
Keep it short and to the point. 0.02. What is the ratio of the Taxes (in constant 2015 US$) in 1962 in Malawi to that in Pakistan?
Make the answer very short. 0.02. What is the ratio of the Taxes (in constant 2015 US$) in 1963 in Malawi to that in Pakistan?
Your response must be concise. 0.02. What is the ratio of the Taxes (in constant 2015 US$) of 1960 in Mauritania to that in Mexico?
Your response must be concise. 0.01. What is the ratio of the Taxes (in constant 2015 US$) in 1961 in Mauritania to that in Mexico?
Provide a short and direct response. 0.01. What is the ratio of the Taxes (in constant 2015 US$) in 1962 in Mauritania to that in Mexico?
Your answer should be very brief. 0.01. What is the ratio of the Taxes (in constant 2015 US$) of 1963 in Mauritania to that in Mexico?
Offer a terse response. 0.01. What is the ratio of the Taxes (in constant 2015 US$) of 1960 in Mauritania to that in Nepal?
Your response must be concise. 0.42. What is the ratio of the Taxes (in constant 2015 US$) of 1961 in Mauritania to that in Nepal?
Offer a very short reply. 0.93. What is the ratio of the Taxes (in constant 2015 US$) in 1962 in Mauritania to that in Nepal?
Make the answer very short. 1.07. What is the ratio of the Taxes (in constant 2015 US$) in 1963 in Mauritania to that in Nepal?
Your answer should be very brief. 1.4. What is the ratio of the Taxes (in constant 2015 US$) of 1960 in Mauritania to that in Nicaragua?
Provide a succinct answer. 0.21. What is the ratio of the Taxes (in constant 2015 US$) of 1961 in Mauritania to that in Nicaragua?
Offer a very short reply. 0.45. What is the ratio of the Taxes (in constant 2015 US$) of 1962 in Mauritania to that in Nicaragua?
Your answer should be compact. 0.5. What is the ratio of the Taxes (in constant 2015 US$) of 1963 in Mauritania to that in Nicaragua?
Provide a short and direct response. 0.48. What is the ratio of the Taxes (in constant 2015 US$) in 1960 in Mauritania to that in Pakistan?
Make the answer very short. 0.01. What is the ratio of the Taxes (in constant 2015 US$) in 1961 in Mauritania to that in Pakistan?
Provide a short and direct response. 0.03. What is the ratio of the Taxes (in constant 2015 US$) of 1962 in Mauritania to that in Pakistan?
Your answer should be compact. 0.03. What is the ratio of the Taxes (in constant 2015 US$) in 1963 in Mauritania to that in Pakistan?
Make the answer very short. 0.04. What is the ratio of the Taxes (in constant 2015 US$) in 1960 in Mexico to that in Nepal?
Ensure brevity in your answer.  76.83. What is the ratio of the Taxes (in constant 2015 US$) of 1961 in Mexico to that in Nepal?
Your response must be concise. 77.06. What is the ratio of the Taxes (in constant 2015 US$) in 1962 in Mexico to that in Nepal?
Offer a very short reply. 78.43. What is the ratio of the Taxes (in constant 2015 US$) in 1963 in Mexico to that in Nepal?
Keep it short and to the point. 98.6. What is the ratio of the Taxes (in constant 2015 US$) of 1960 in Mexico to that in Nicaragua?
Offer a very short reply. 37.85. What is the ratio of the Taxes (in constant 2015 US$) in 1961 in Mexico to that in Nicaragua?
Give a very brief answer. 37.62. What is the ratio of the Taxes (in constant 2015 US$) of 1962 in Mexico to that in Nicaragua?
Keep it short and to the point. 36.8. What is the ratio of the Taxes (in constant 2015 US$) in 1963 in Mexico to that in Nicaragua?
Your answer should be very brief. 33.84. What is the ratio of the Taxes (in constant 2015 US$) of 1960 in Mexico to that in Pakistan?
Provide a succinct answer. 2.67. What is the ratio of the Taxes (in constant 2015 US$) in 1961 in Mexico to that in Pakistan?
Give a very brief answer. 2.37. What is the ratio of the Taxes (in constant 2015 US$) in 1962 in Mexico to that in Pakistan?
Provide a succinct answer. 2.5. What is the ratio of the Taxes (in constant 2015 US$) in 1963 in Mexico to that in Pakistan?
Your answer should be very brief. 2.49. What is the ratio of the Taxes (in constant 2015 US$) of 1960 in Nepal to that in Nicaragua?
Your response must be concise. 0.49. What is the ratio of the Taxes (in constant 2015 US$) in 1961 in Nepal to that in Nicaragua?
Make the answer very short. 0.49. What is the ratio of the Taxes (in constant 2015 US$) in 1962 in Nepal to that in Nicaragua?
Your answer should be very brief. 0.47. What is the ratio of the Taxes (in constant 2015 US$) of 1963 in Nepal to that in Nicaragua?
Your answer should be very brief. 0.34. What is the ratio of the Taxes (in constant 2015 US$) in 1960 in Nepal to that in Pakistan?
Provide a short and direct response. 0.03. What is the ratio of the Taxes (in constant 2015 US$) in 1961 in Nepal to that in Pakistan?
Offer a very short reply. 0.03. What is the ratio of the Taxes (in constant 2015 US$) of 1962 in Nepal to that in Pakistan?
Your response must be concise. 0.03. What is the ratio of the Taxes (in constant 2015 US$) of 1963 in Nepal to that in Pakistan?
Ensure brevity in your answer.  0.03. What is the ratio of the Taxes (in constant 2015 US$) in 1960 in Nicaragua to that in Pakistan?
Your response must be concise. 0.07. What is the ratio of the Taxes (in constant 2015 US$) of 1961 in Nicaragua to that in Pakistan?
Offer a terse response. 0.06. What is the ratio of the Taxes (in constant 2015 US$) of 1962 in Nicaragua to that in Pakistan?
Keep it short and to the point. 0.07. What is the ratio of the Taxes (in constant 2015 US$) of 1963 in Nicaragua to that in Pakistan?
Keep it short and to the point. 0.07. What is the difference between the highest and the second highest Taxes (in constant 2015 US$) of 1960?
Provide a short and direct response. 3.41e+08. What is the difference between the highest and the second highest Taxes (in constant 2015 US$) in 1961?
Ensure brevity in your answer.  3.27e+08. What is the difference between the highest and the second highest Taxes (in constant 2015 US$) of 1962?
Ensure brevity in your answer.  3.76e+08. What is the difference between the highest and the second highest Taxes (in constant 2015 US$) of 1963?
Your response must be concise. 4.06e+08. What is the difference between the highest and the lowest Taxes (in constant 2015 US$) in 1960?
Your response must be concise. 5.42e+08. What is the difference between the highest and the lowest Taxes (in constant 2015 US$) of 1961?
Your answer should be compact. 5.61e+08. What is the difference between the highest and the lowest Taxes (in constant 2015 US$) of 1962?
Ensure brevity in your answer.  6.22e+08. What is the difference between the highest and the lowest Taxes (in constant 2015 US$) of 1963?
Give a very brief answer. 6.73e+08. 